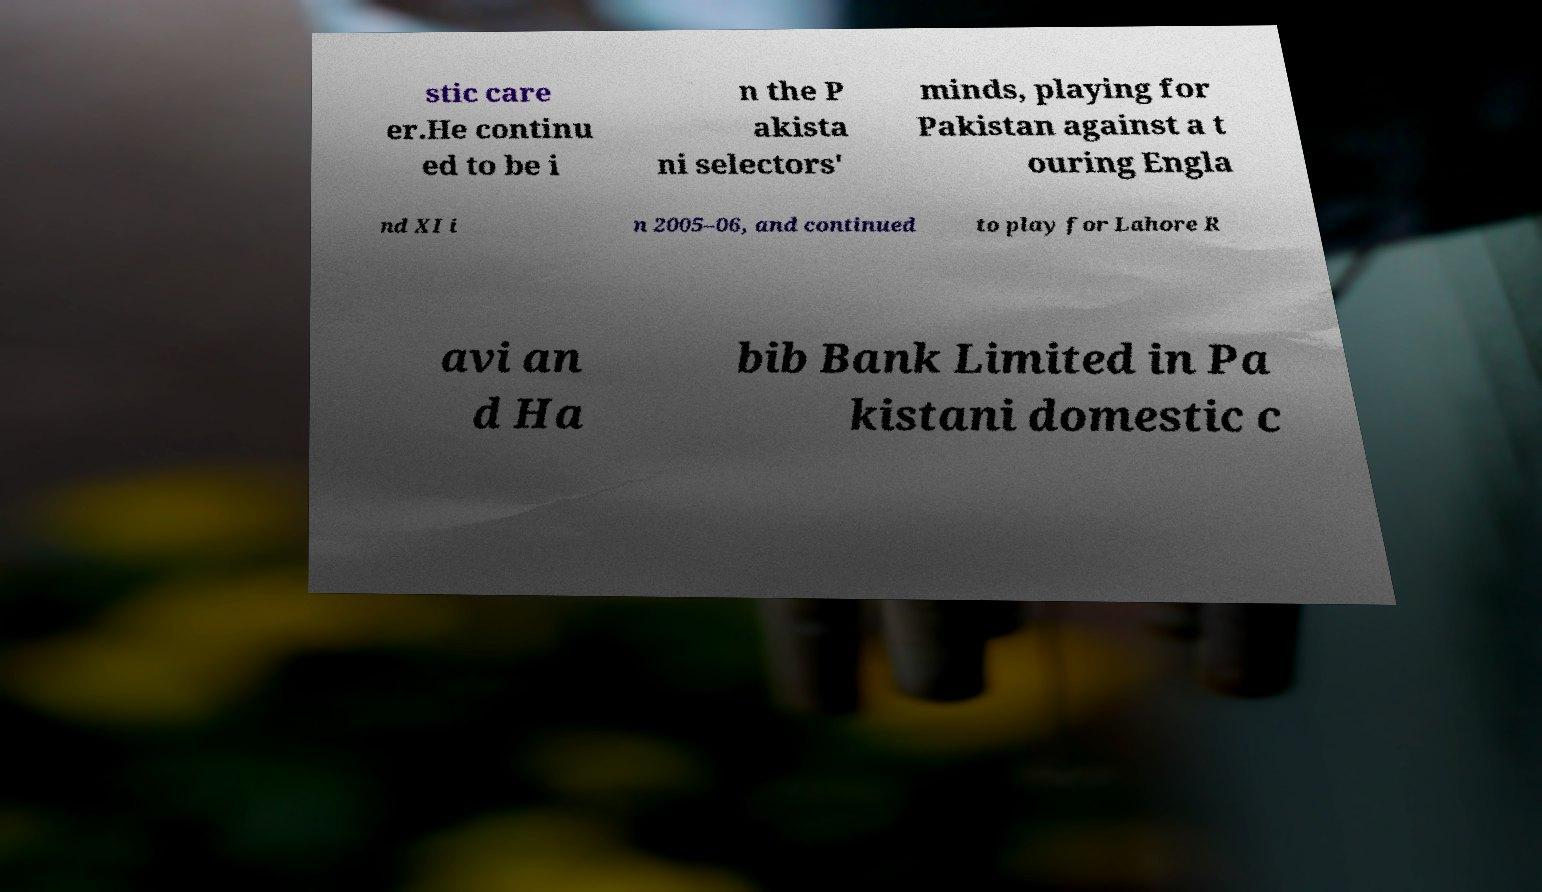Can you read and provide the text displayed in the image?This photo seems to have some interesting text. Can you extract and type it out for me? stic care er.He continu ed to be i n the P akista ni selectors' minds, playing for Pakistan against a t ouring Engla nd XI i n 2005–06, and continued to play for Lahore R avi an d Ha bib Bank Limited in Pa kistani domestic c 